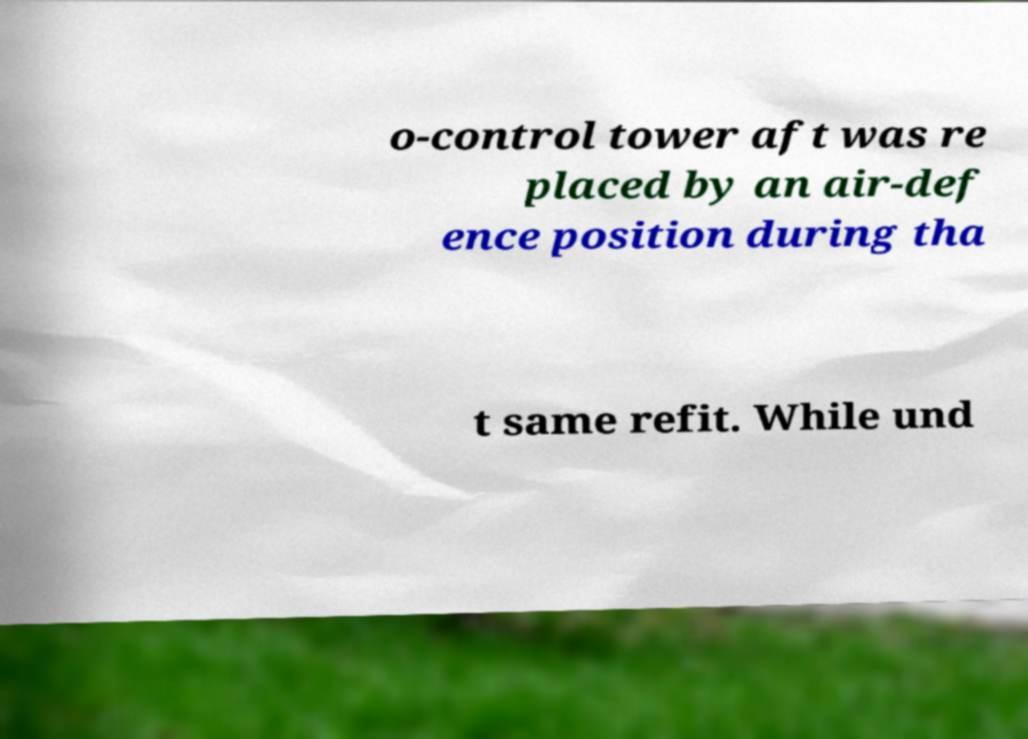Can you accurately transcribe the text from the provided image for me? o-control tower aft was re placed by an air-def ence position during tha t same refit. While und 